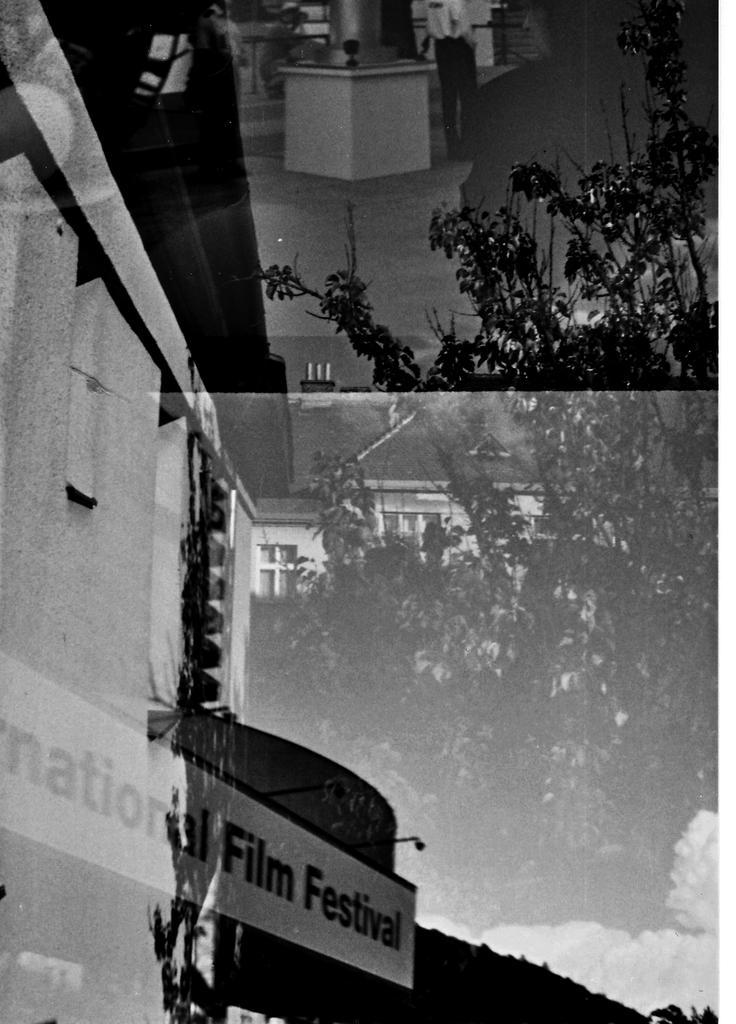In one or two sentences, can you explain what this image depicts? In this image I can see buildings, tree and some text over here. This picture is black and white in color. 